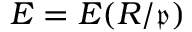<formula> <loc_0><loc_0><loc_500><loc_500>E = E ( R / { \mathfrak { p } } )</formula> 